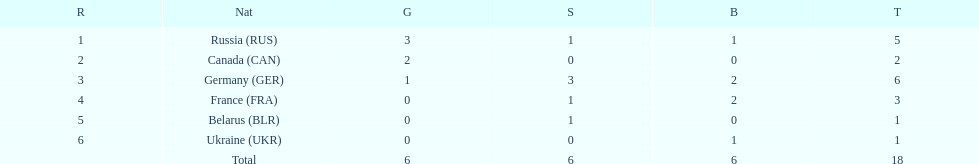What were the only 3 countries to win gold medals at the the 1994 winter olympics biathlon? Russia (RUS), Canada (CAN), Germany (GER). 